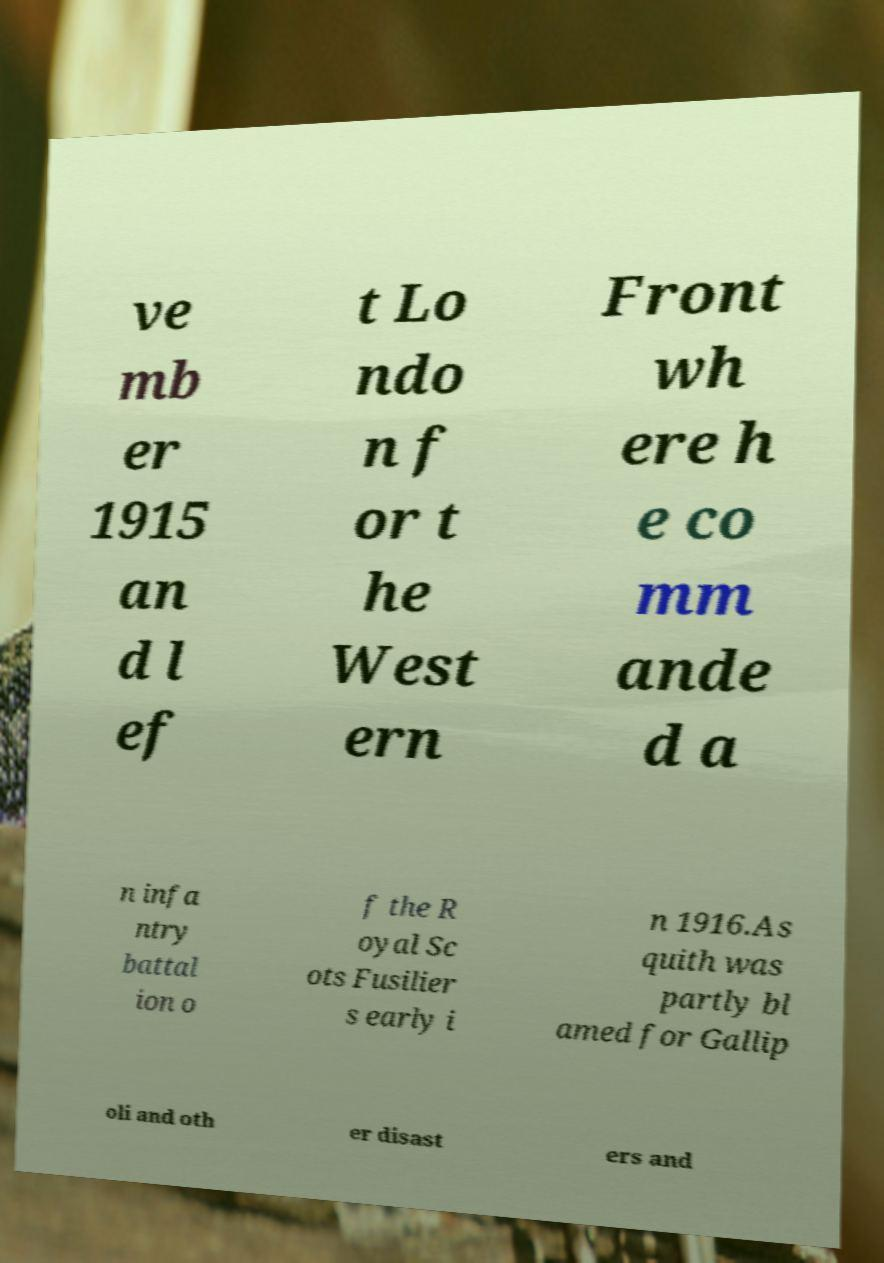Can you read and provide the text displayed in the image?This photo seems to have some interesting text. Can you extract and type it out for me? ve mb er 1915 an d l ef t Lo ndo n f or t he West ern Front wh ere h e co mm ande d a n infa ntry battal ion o f the R oyal Sc ots Fusilier s early i n 1916.As quith was partly bl amed for Gallip oli and oth er disast ers and 